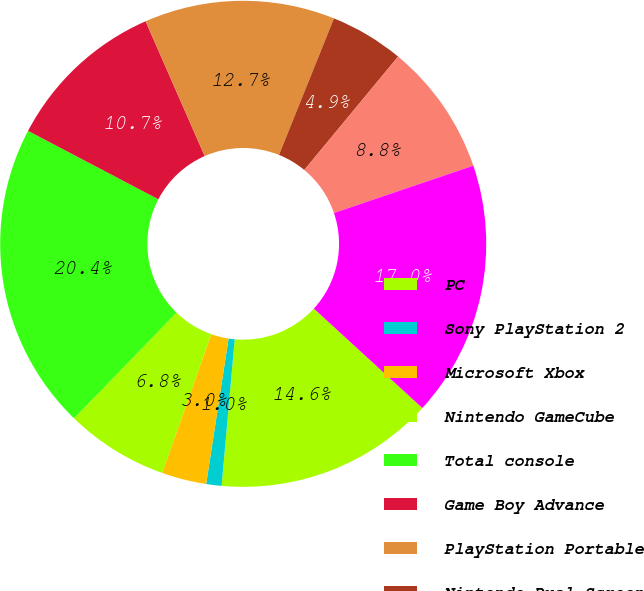Convert chart to OTSL. <chart><loc_0><loc_0><loc_500><loc_500><pie_chart><fcel>PC<fcel>Sony PlayStation 2<fcel>Microsoft Xbox<fcel>Nintendo GameCube<fcel>Total console<fcel>Game Boy Advance<fcel>PlayStation Portable<fcel>Nintendo Dual Screen<fcel>Total hand-held<fcel>Total publishing net revenues<nl><fcel>14.61%<fcel>1.02%<fcel>2.97%<fcel>6.85%<fcel>20.44%<fcel>10.73%<fcel>12.67%<fcel>4.91%<fcel>8.79%<fcel>17.02%<nl></chart> 